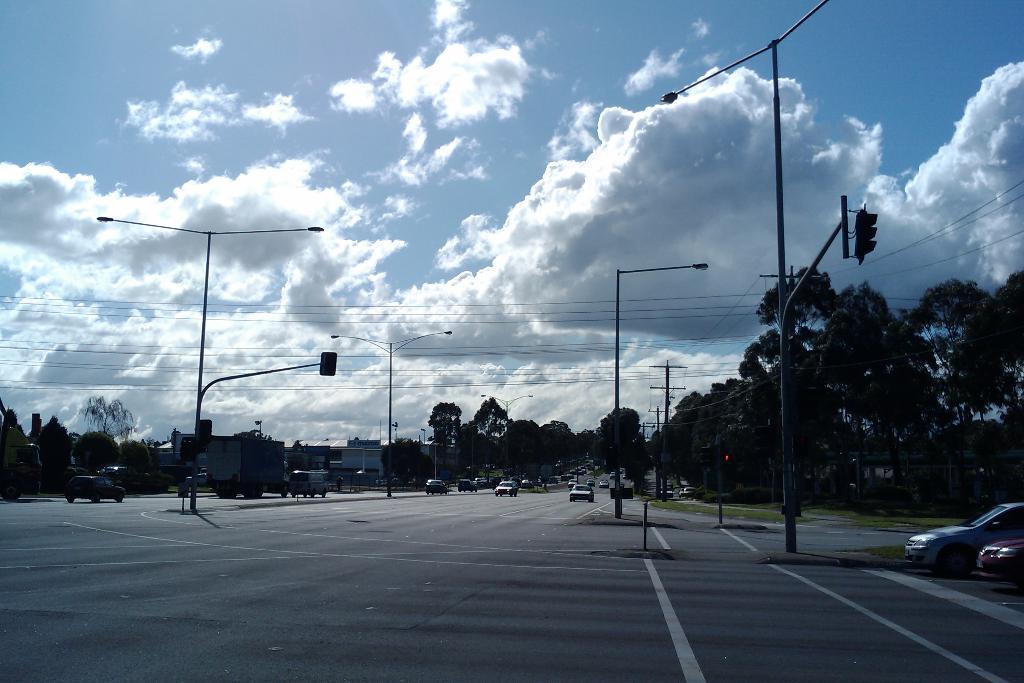Describe this image in one or two sentences. On the road many vehicles are moving. There are street lights. In the background there are roads, buildings. The sky is cloudy. 